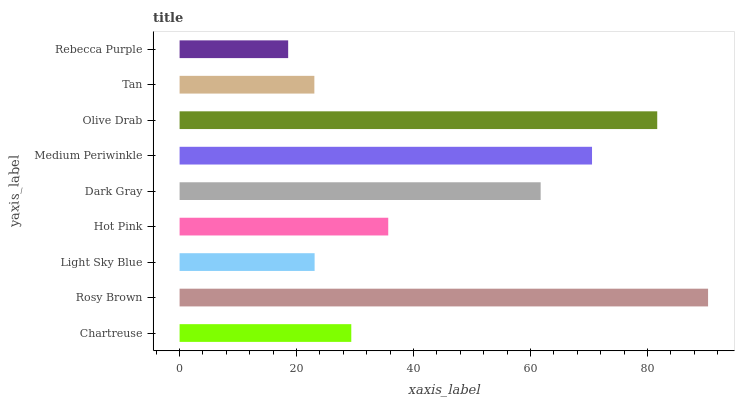Is Rebecca Purple the minimum?
Answer yes or no. Yes. Is Rosy Brown the maximum?
Answer yes or no. Yes. Is Light Sky Blue the minimum?
Answer yes or no. No. Is Light Sky Blue the maximum?
Answer yes or no. No. Is Rosy Brown greater than Light Sky Blue?
Answer yes or no. Yes. Is Light Sky Blue less than Rosy Brown?
Answer yes or no. Yes. Is Light Sky Blue greater than Rosy Brown?
Answer yes or no. No. Is Rosy Brown less than Light Sky Blue?
Answer yes or no. No. Is Hot Pink the high median?
Answer yes or no. Yes. Is Hot Pink the low median?
Answer yes or no. Yes. Is Rebecca Purple the high median?
Answer yes or no. No. Is Dark Gray the low median?
Answer yes or no. No. 